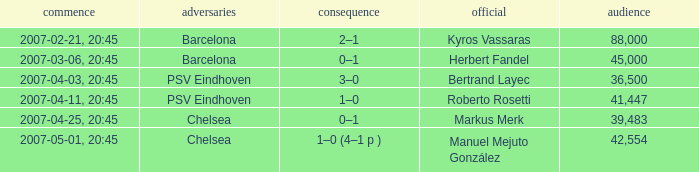WHAT OPPONENT HAD A KICKOFF OF 2007-03-06, 20:45? Barcelona. 